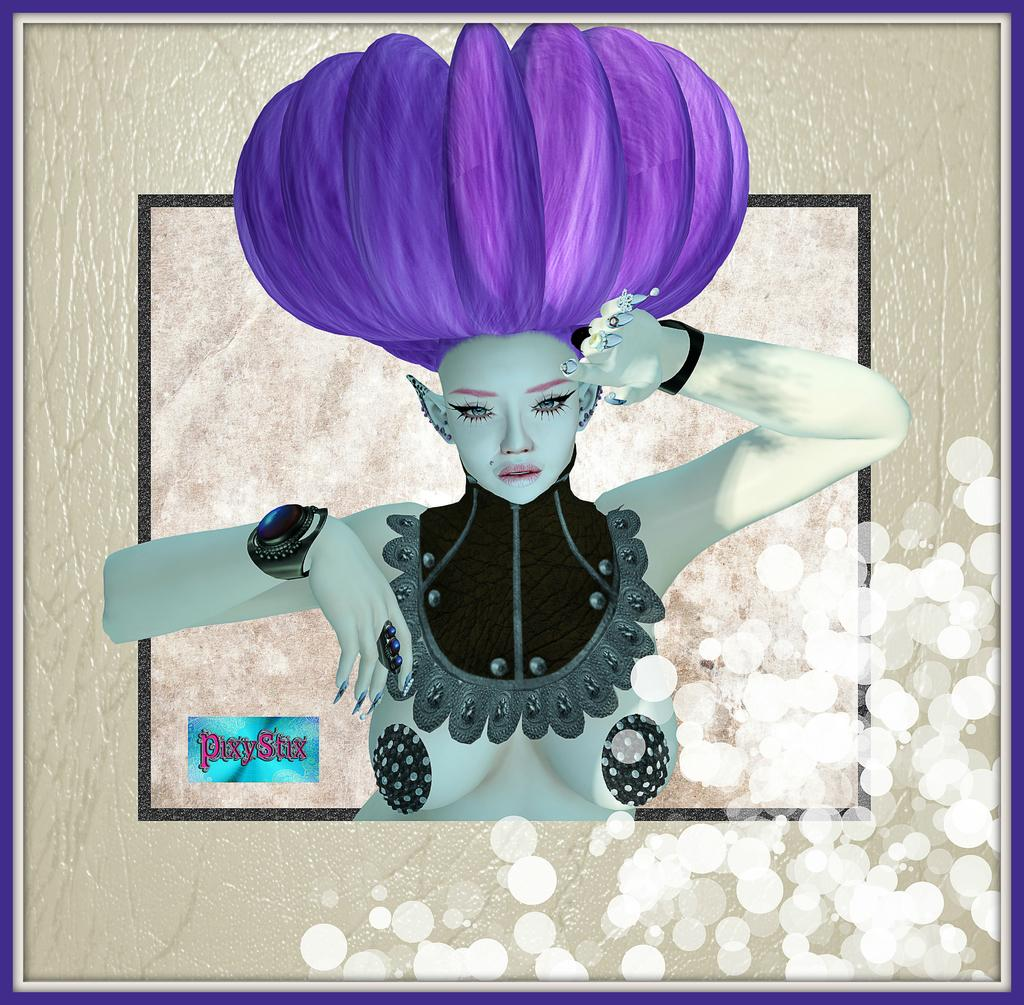What is the main subject of the image? The main subject of the image is a frame. What can be seen inside the frame? There is a woman in the frame. Are there any words or phrases in the image? Yes, there is text in the frame. What color is the lead in the image? There is no lead present in the image, and therefore no color can be determined. 